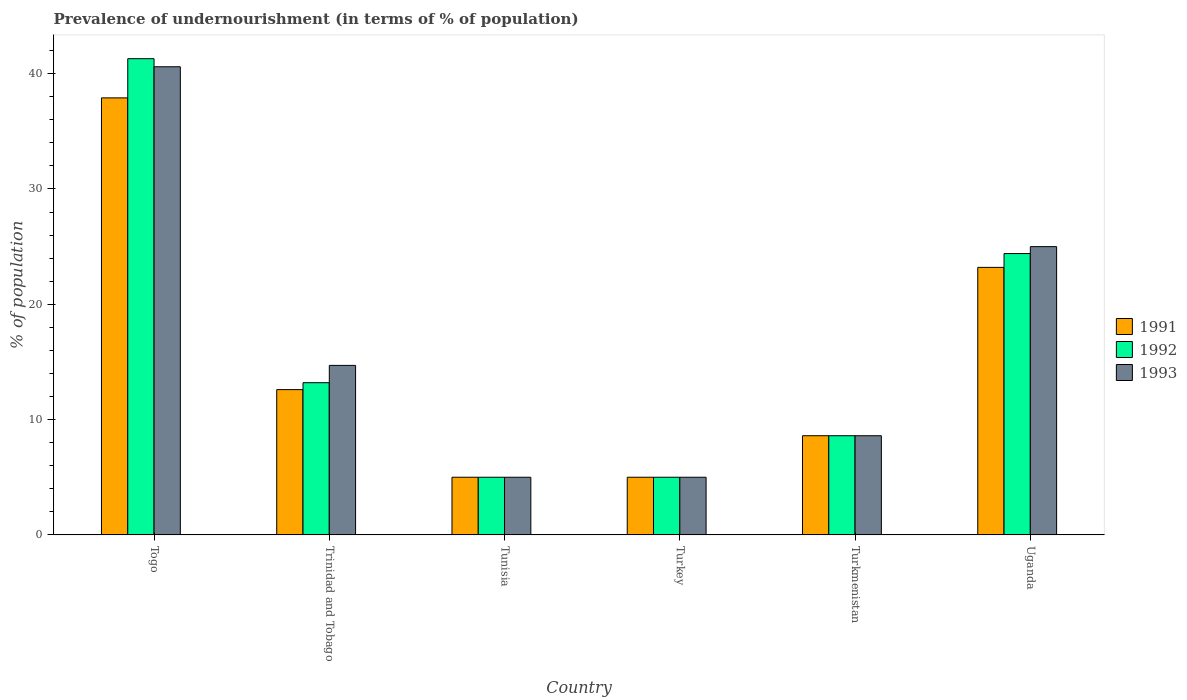Are the number of bars per tick equal to the number of legend labels?
Your response must be concise. Yes. Are the number of bars on each tick of the X-axis equal?
Your response must be concise. Yes. How many bars are there on the 6th tick from the left?
Your answer should be very brief. 3. What is the label of the 6th group of bars from the left?
Provide a succinct answer. Uganda. Across all countries, what is the maximum percentage of undernourished population in 1992?
Your answer should be compact. 41.3. In which country was the percentage of undernourished population in 1993 maximum?
Provide a succinct answer. Togo. In which country was the percentage of undernourished population in 1993 minimum?
Provide a short and direct response. Tunisia. What is the total percentage of undernourished population in 1991 in the graph?
Offer a terse response. 92.3. What is the difference between the percentage of undernourished population in 1991 in Tunisia and the percentage of undernourished population in 1992 in Trinidad and Tobago?
Make the answer very short. -8.2. What is the average percentage of undernourished population in 1991 per country?
Your response must be concise. 15.38. In how many countries, is the percentage of undernourished population in 1992 greater than 32 %?
Offer a very short reply. 1. What is the ratio of the percentage of undernourished population in 1993 in Turkmenistan to that in Uganda?
Keep it short and to the point. 0.34. What is the difference between the highest and the second highest percentage of undernourished population in 1991?
Your answer should be very brief. -25.3. What is the difference between the highest and the lowest percentage of undernourished population in 1992?
Give a very brief answer. 36.3. In how many countries, is the percentage of undernourished population in 1993 greater than the average percentage of undernourished population in 1993 taken over all countries?
Your answer should be compact. 2. What does the 3rd bar from the left in Togo represents?
Keep it short and to the point. 1993. What does the 3rd bar from the right in Uganda represents?
Ensure brevity in your answer.  1991. How many bars are there?
Your answer should be compact. 18. Where does the legend appear in the graph?
Provide a short and direct response. Center right. What is the title of the graph?
Provide a succinct answer. Prevalence of undernourishment (in terms of % of population). Does "2005" appear as one of the legend labels in the graph?
Your response must be concise. No. What is the label or title of the X-axis?
Provide a short and direct response. Country. What is the label or title of the Y-axis?
Make the answer very short. % of population. What is the % of population of 1991 in Togo?
Ensure brevity in your answer.  37.9. What is the % of population in 1992 in Togo?
Provide a short and direct response. 41.3. What is the % of population in 1993 in Togo?
Offer a terse response. 40.6. What is the % of population of 1991 in Trinidad and Tobago?
Your response must be concise. 12.6. What is the % of population of 1992 in Trinidad and Tobago?
Provide a short and direct response. 13.2. What is the % of population of 1991 in Tunisia?
Ensure brevity in your answer.  5. What is the % of population of 1992 in Turkey?
Ensure brevity in your answer.  5. What is the % of population in 1993 in Turkey?
Ensure brevity in your answer.  5. What is the % of population of 1991 in Turkmenistan?
Ensure brevity in your answer.  8.6. What is the % of population in 1992 in Turkmenistan?
Your response must be concise. 8.6. What is the % of population in 1991 in Uganda?
Your response must be concise. 23.2. What is the % of population of 1992 in Uganda?
Ensure brevity in your answer.  24.4. Across all countries, what is the maximum % of population of 1991?
Your response must be concise. 37.9. Across all countries, what is the maximum % of population in 1992?
Keep it short and to the point. 41.3. Across all countries, what is the maximum % of population of 1993?
Offer a terse response. 40.6. Across all countries, what is the minimum % of population in 1991?
Ensure brevity in your answer.  5. What is the total % of population in 1991 in the graph?
Provide a short and direct response. 92.3. What is the total % of population in 1992 in the graph?
Make the answer very short. 97.5. What is the total % of population in 1993 in the graph?
Make the answer very short. 98.9. What is the difference between the % of population of 1991 in Togo and that in Trinidad and Tobago?
Offer a terse response. 25.3. What is the difference between the % of population of 1992 in Togo and that in Trinidad and Tobago?
Ensure brevity in your answer.  28.1. What is the difference between the % of population in 1993 in Togo and that in Trinidad and Tobago?
Provide a succinct answer. 25.9. What is the difference between the % of population in 1991 in Togo and that in Tunisia?
Your response must be concise. 32.9. What is the difference between the % of population of 1992 in Togo and that in Tunisia?
Provide a succinct answer. 36.3. What is the difference between the % of population of 1993 in Togo and that in Tunisia?
Offer a terse response. 35.6. What is the difference between the % of population in 1991 in Togo and that in Turkey?
Ensure brevity in your answer.  32.9. What is the difference between the % of population of 1992 in Togo and that in Turkey?
Your answer should be very brief. 36.3. What is the difference between the % of population in 1993 in Togo and that in Turkey?
Offer a very short reply. 35.6. What is the difference between the % of population of 1991 in Togo and that in Turkmenistan?
Ensure brevity in your answer.  29.3. What is the difference between the % of population of 1992 in Togo and that in Turkmenistan?
Keep it short and to the point. 32.7. What is the difference between the % of population in 1993 in Togo and that in Turkmenistan?
Your response must be concise. 32. What is the difference between the % of population in 1991 in Togo and that in Uganda?
Offer a terse response. 14.7. What is the difference between the % of population in 1992 in Togo and that in Uganda?
Offer a very short reply. 16.9. What is the difference between the % of population of 1993 in Togo and that in Uganda?
Give a very brief answer. 15.6. What is the difference between the % of population in 1992 in Trinidad and Tobago and that in Tunisia?
Give a very brief answer. 8.2. What is the difference between the % of population of 1993 in Trinidad and Tobago and that in Tunisia?
Your response must be concise. 9.7. What is the difference between the % of population in 1991 in Trinidad and Tobago and that in Turkey?
Your answer should be compact. 7.6. What is the difference between the % of population of 1993 in Trinidad and Tobago and that in Turkey?
Make the answer very short. 9.7. What is the difference between the % of population of 1993 in Trinidad and Tobago and that in Turkmenistan?
Keep it short and to the point. 6.1. What is the difference between the % of population in 1991 in Trinidad and Tobago and that in Uganda?
Provide a succinct answer. -10.6. What is the difference between the % of population of 1993 in Trinidad and Tobago and that in Uganda?
Keep it short and to the point. -10.3. What is the difference between the % of population of 1991 in Tunisia and that in Turkey?
Your response must be concise. 0. What is the difference between the % of population of 1992 in Tunisia and that in Turkey?
Provide a succinct answer. 0. What is the difference between the % of population in 1992 in Tunisia and that in Turkmenistan?
Ensure brevity in your answer.  -3.6. What is the difference between the % of population in 1991 in Tunisia and that in Uganda?
Offer a very short reply. -18.2. What is the difference between the % of population in 1992 in Tunisia and that in Uganda?
Your answer should be very brief. -19.4. What is the difference between the % of population of 1993 in Tunisia and that in Uganda?
Give a very brief answer. -20. What is the difference between the % of population in 1991 in Turkey and that in Turkmenistan?
Make the answer very short. -3.6. What is the difference between the % of population of 1993 in Turkey and that in Turkmenistan?
Keep it short and to the point. -3.6. What is the difference between the % of population of 1991 in Turkey and that in Uganda?
Your answer should be very brief. -18.2. What is the difference between the % of population in 1992 in Turkey and that in Uganda?
Your answer should be very brief. -19.4. What is the difference between the % of population of 1993 in Turkey and that in Uganda?
Give a very brief answer. -20. What is the difference between the % of population in 1991 in Turkmenistan and that in Uganda?
Ensure brevity in your answer.  -14.6. What is the difference between the % of population in 1992 in Turkmenistan and that in Uganda?
Offer a very short reply. -15.8. What is the difference between the % of population of 1993 in Turkmenistan and that in Uganda?
Offer a very short reply. -16.4. What is the difference between the % of population in 1991 in Togo and the % of population in 1992 in Trinidad and Tobago?
Provide a succinct answer. 24.7. What is the difference between the % of population in 1991 in Togo and the % of population in 1993 in Trinidad and Tobago?
Make the answer very short. 23.2. What is the difference between the % of population of 1992 in Togo and the % of population of 1993 in Trinidad and Tobago?
Ensure brevity in your answer.  26.6. What is the difference between the % of population in 1991 in Togo and the % of population in 1992 in Tunisia?
Give a very brief answer. 32.9. What is the difference between the % of population of 1991 in Togo and the % of population of 1993 in Tunisia?
Ensure brevity in your answer.  32.9. What is the difference between the % of population of 1992 in Togo and the % of population of 1993 in Tunisia?
Give a very brief answer. 36.3. What is the difference between the % of population of 1991 in Togo and the % of population of 1992 in Turkey?
Keep it short and to the point. 32.9. What is the difference between the % of population of 1991 in Togo and the % of population of 1993 in Turkey?
Ensure brevity in your answer.  32.9. What is the difference between the % of population of 1992 in Togo and the % of population of 1993 in Turkey?
Provide a short and direct response. 36.3. What is the difference between the % of population in 1991 in Togo and the % of population in 1992 in Turkmenistan?
Offer a very short reply. 29.3. What is the difference between the % of population in 1991 in Togo and the % of population in 1993 in Turkmenistan?
Offer a very short reply. 29.3. What is the difference between the % of population of 1992 in Togo and the % of population of 1993 in Turkmenistan?
Give a very brief answer. 32.7. What is the difference between the % of population in 1991 in Togo and the % of population in 1993 in Uganda?
Keep it short and to the point. 12.9. What is the difference between the % of population in 1991 in Trinidad and Tobago and the % of population in 1992 in Tunisia?
Provide a short and direct response. 7.6. What is the difference between the % of population in 1992 in Trinidad and Tobago and the % of population in 1993 in Tunisia?
Give a very brief answer. 8.2. What is the difference between the % of population in 1991 in Trinidad and Tobago and the % of population in 1992 in Turkey?
Offer a terse response. 7.6. What is the difference between the % of population of 1991 in Trinidad and Tobago and the % of population of 1993 in Turkey?
Provide a succinct answer. 7.6. What is the difference between the % of population in 1991 in Trinidad and Tobago and the % of population in 1992 in Turkmenistan?
Keep it short and to the point. 4. What is the difference between the % of population in 1991 in Tunisia and the % of population in 1992 in Turkey?
Give a very brief answer. 0. What is the difference between the % of population in 1991 in Tunisia and the % of population in 1993 in Turkey?
Your answer should be very brief. 0. What is the difference between the % of population of 1992 in Tunisia and the % of population of 1993 in Turkey?
Ensure brevity in your answer.  0. What is the difference between the % of population in 1991 in Tunisia and the % of population in 1992 in Turkmenistan?
Provide a short and direct response. -3.6. What is the difference between the % of population of 1991 in Tunisia and the % of population of 1993 in Turkmenistan?
Your answer should be very brief. -3.6. What is the difference between the % of population in 1991 in Tunisia and the % of population in 1992 in Uganda?
Provide a short and direct response. -19.4. What is the difference between the % of population of 1991 in Tunisia and the % of population of 1993 in Uganda?
Provide a succinct answer. -20. What is the difference between the % of population in 1991 in Turkey and the % of population in 1992 in Uganda?
Give a very brief answer. -19.4. What is the difference between the % of population in 1991 in Turkey and the % of population in 1993 in Uganda?
Make the answer very short. -20. What is the difference between the % of population in 1991 in Turkmenistan and the % of population in 1992 in Uganda?
Your response must be concise. -15.8. What is the difference between the % of population of 1991 in Turkmenistan and the % of population of 1993 in Uganda?
Keep it short and to the point. -16.4. What is the difference between the % of population in 1992 in Turkmenistan and the % of population in 1993 in Uganda?
Your response must be concise. -16.4. What is the average % of population in 1991 per country?
Offer a terse response. 15.38. What is the average % of population in 1992 per country?
Your answer should be compact. 16.25. What is the average % of population of 1993 per country?
Give a very brief answer. 16.48. What is the difference between the % of population in 1991 and % of population in 1992 in Turkey?
Make the answer very short. 0. What is the difference between the % of population in 1991 and % of population in 1993 in Turkey?
Your answer should be compact. 0. What is the difference between the % of population of 1991 and % of population of 1993 in Turkmenistan?
Keep it short and to the point. 0. What is the difference between the % of population in 1992 and % of population in 1993 in Turkmenistan?
Keep it short and to the point. 0. What is the difference between the % of population in 1991 and % of population in 1992 in Uganda?
Your answer should be compact. -1.2. What is the difference between the % of population of 1991 and % of population of 1993 in Uganda?
Offer a very short reply. -1.8. What is the difference between the % of population of 1992 and % of population of 1993 in Uganda?
Give a very brief answer. -0.6. What is the ratio of the % of population in 1991 in Togo to that in Trinidad and Tobago?
Your response must be concise. 3.01. What is the ratio of the % of population in 1992 in Togo to that in Trinidad and Tobago?
Make the answer very short. 3.13. What is the ratio of the % of population in 1993 in Togo to that in Trinidad and Tobago?
Your answer should be compact. 2.76. What is the ratio of the % of population in 1991 in Togo to that in Tunisia?
Keep it short and to the point. 7.58. What is the ratio of the % of population in 1992 in Togo to that in Tunisia?
Offer a terse response. 8.26. What is the ratio of the % of population in 1993 in Togo to that in Tunisia?
Ensure brevity in your answer.  8.12. What is the ratio of the % of population of 1991 in Togo to that in Turkey?
Your answer should be very brief. 7.58. What is the ratio of the % of population in 1992 in Togo to that in Turkey?
Your response must be concise. 8.26. What is the ratio of the % of population in 1993 in Togo to that in Turkey?
Offer a very short reply. 8.12. What is the ratio of the % of population of 1991 in Togo to that in Turkmenistan?
Your response must be concise. 4.41. What is the ratio of the % of population of 1992 in Togo to that in Turkmenistan?
Make the answer very short. 4.8. What is the ratio of the % of population of 1993 in Togo to that in Turkmenistan?
Your answer should be very brief. 4.72. What is the ratio of the % of population of 1991 in Togo to that in Uganda?
Offer a terse response. 1.63. What is the ratio of the % of population in 1992 in Togo to that in Uganda?
Provide a short and direct response. 1.69. What is the ratio of the % of population in 1993 in Togo to that in Uganda?
Provide a succinct answer. 1.62. What is the ratio of the % of population of 1991 in Trinidad and Tobago to that in Tunisia?
Provide a succinct answer. 2.52. What is the ratio of the % of population of 1992 in Trinidad and Tobago to that in Tunisia?
Offer a terse response. 2.64. What is the ratio of the % of population of 1993 in Trinidad and Tobago to that in Tunisia?
Your answer should be very brief. 2.94. What is the ratio of the % of population in 1991 in Trinidad and Tobago to that in Turkey?
Ensure brevity in your answer.  2.52. What is the ratio of the % of population in 1992 in Trinidad and Tobago to that in Turkey?
Your answer should be very brief. 2.64. What is the ratio of the % of population of 1993 in Trinidad and Tobago to that in Turkey?
Give a very brief answer. 2.94. What is the ratio of the % of population of 1991 in Trinidad and Tobago to that in Turkmenistan?
Your answer should be compact. 1.47. What is the ratio of the % of population in 1992 in Trinidad and Tobago to that in Turkmenistan?
Provide a short and direct response. 1.53. What is the ratio of the % of population in 1993 in Trinidad and Tobago to that in Turkmenistan?
Keep it short and to the point. 1.71. What is the ratio of the % of population in 1991 in Trinidad and Tobago to that in Uganda?
Give a very brief answer. 0.54. What is the ratio of the % of population of 1992 in Trinidad and Tobago to that in Uganda?
Your answer should be compact. 0.54. What is the ratio of the % of population in 1993 in Trinidad and Tobago to that in Uganda?
Keep it short and to the point. 0.59. What is the ratio of the % of population of 1991 in Tunisia to that in Turkey?
Ensure brevity in your answer.  1. What is the ratio of the % of population in 1993 in Tunisia to that in Turkey?
Your response must be concise. 1. What is the ratio of the % of population in 1991 in Tunisia to that in Turkmenistan?
Offer a terse response. 0.58. What is the ratio of the % of population of 1992 in Tunisia to that in Turkmenistan?
Make the answer very short. 0.58. What is the ratio of the % of population of 1993 in Tunisia to that in Turkmenistan?
Ensure brevity in your answer.  0.58. What is the ratio of the % of population in 1991 in Tunisia to that in Uganda?
Provide a succinct answer. 0.22. What is the ratio of the % of population in 1992 in Tunisia to that in Uganda?
Your answer should be very brief. 0.2. What is the ratio of the % of population of 1991 in Turkey to that in Turkmenistan?
Ensure brevity in your answer.  0.58. What is the ratio of the % of population of 1992 in Turkey to that in Turkmenistan?
Ensure brevity in your answer.  0.58. What is the ratio of the % of population in 1993 in Turkey to that in Turkmenistan?
Make the answer very short. 0.58. What is the ratio of the % of population in 1991 in Turkey to that in Uganda?
Ensure brevity in your answer.  0.22. What is the ratio of the % of population in 1992 in Turkey to that in Uganda?
Offer a very short reply. 0.2. What is the ratio of the % of population of 1991 in Turkmenistan to that in Uganda?
Offer a very short reply. 0.37. What is the ratio of the % of population of 1992 in Turkmenistan to that in Uganda?
Offer a terse response. 0.35. What is the ratio of the % of population of 1993 in Turkmenistan to that in Uganda?
Your response must be concise. 0.34. What is the difference between the highest and the second highest % of population of 1993?
Keep it short and to the point. 15.6. What is the difference between the highest and the lowest % of population of 1991?
Offer a terse response. 32.9. What is the difference between the highest and the lowest % of population of 1992?
Offer a very short reply. 36.3. What is the difference between the highest and the lowest % of population of 1993?
Your answer should be very brief. 35.6. 